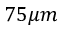<formula> <loc_0><loc_0><loc_500><loc_500>7 5 \mu m</formula> 